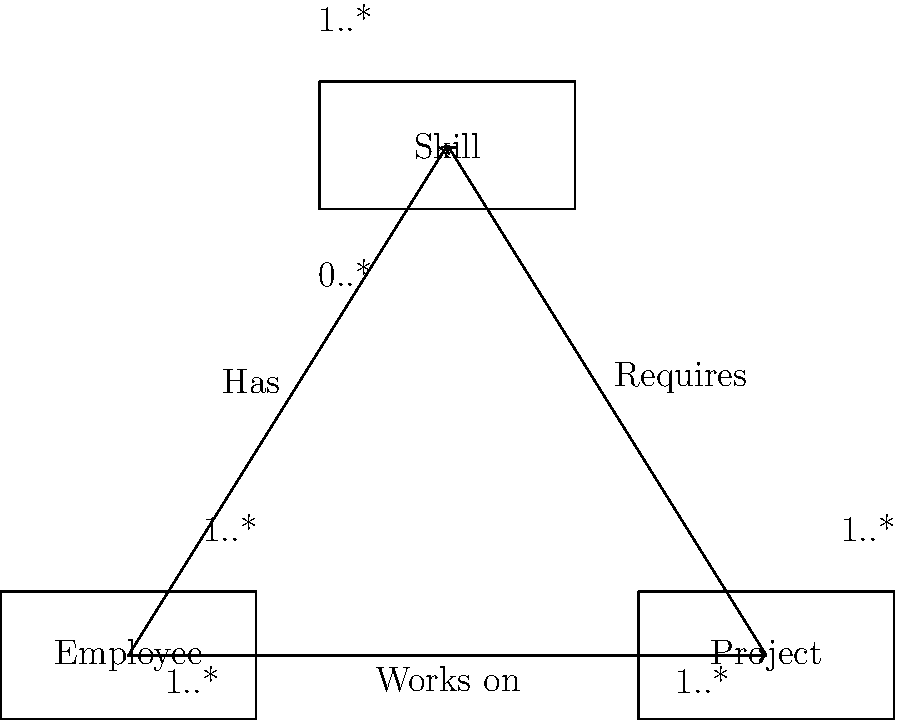Based on the given entity-relationship diagram, which of the following statements is true about the relationship between Employee, Project, and Skill entities?

A) An employee must work on at least one project and have at least one skill.
B) A project can exist without any employees working on it.
C) A skill can exist in the database without being associated with any employees or projects.
D) An employee can work on multiple projects, but each project requires only one skill. Let's analyze the entity-relationship diagram step by step:

1. Employee-Project relationship:
   - The "Works on" relationship has cardinality 1..* on both sides.
   - This means an employee must work on at least one project, and each project must have at least one employee.

2. Employee-Skill relationship:
   - The "Has" relationship has cardinality 1..* on both sides.
   - This indicates an employee must have at least one skill, and each skill must be possessed by at least one employee.

3. Project-Skill relationship:
   - The "Requires" relationship has cardinality 1..* on the Project side and 0..* on the Skill side.
   - This means a project must require at least one skill, but a skill may or may not be required by any project.

Now, let's evaluate each option:

A) Correct. An employee must work on at least one project (1..* cardinality) and have at least one skill (1..* cardinality).
B) Incorrect. A project must have at least one employee working on it (1..* cardinality).
C) Correct. A skill can exist without being associated with any project (0..* cardinality), but it must be associated with at least one employee (1..* cardinality).
D) Incorrect. While an employee can work on multiple projects, each project requires at least one skill (1..* cardinality), not only one.

Based on this analysis, the correct statement is option A.
Answer: A 